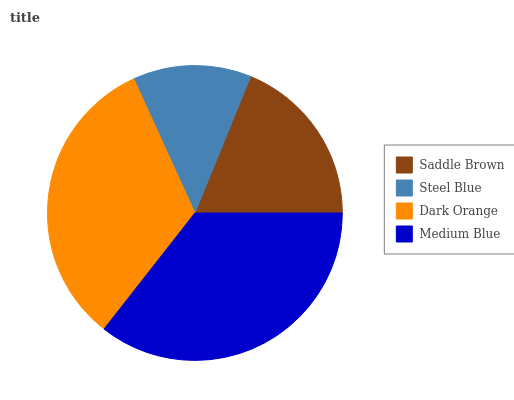Is Steel Blue the minimum?
Answer yes or no. Yes. Is Medium Blue the maximum?
Answer yes or no. Yes. Is Dark Orange the minimum?
Answer yes or no. No. Is Dark Orange the maximum?
Answer yes or no. No. Is Dark Orange greater than Steel Blue?
Answer yes or no. Yes. Is Steel Blue less than Dark Orange?
Answer yes or no. Yes. Is Steel Blue greater than Dark Orange?
Answer yes or no. No. Is Dark Orange less than Steel Blue?
Answer yes or no. No. Is Dark Orange the high median?
Answer yes or no. Yes. Is Saddle Brown the low median?
Answer yes or no. Yes. Is Saddle Brown the high median?
Answer yes or no. No. Is Medium Blue the low median?
Answer yes or no. No. 